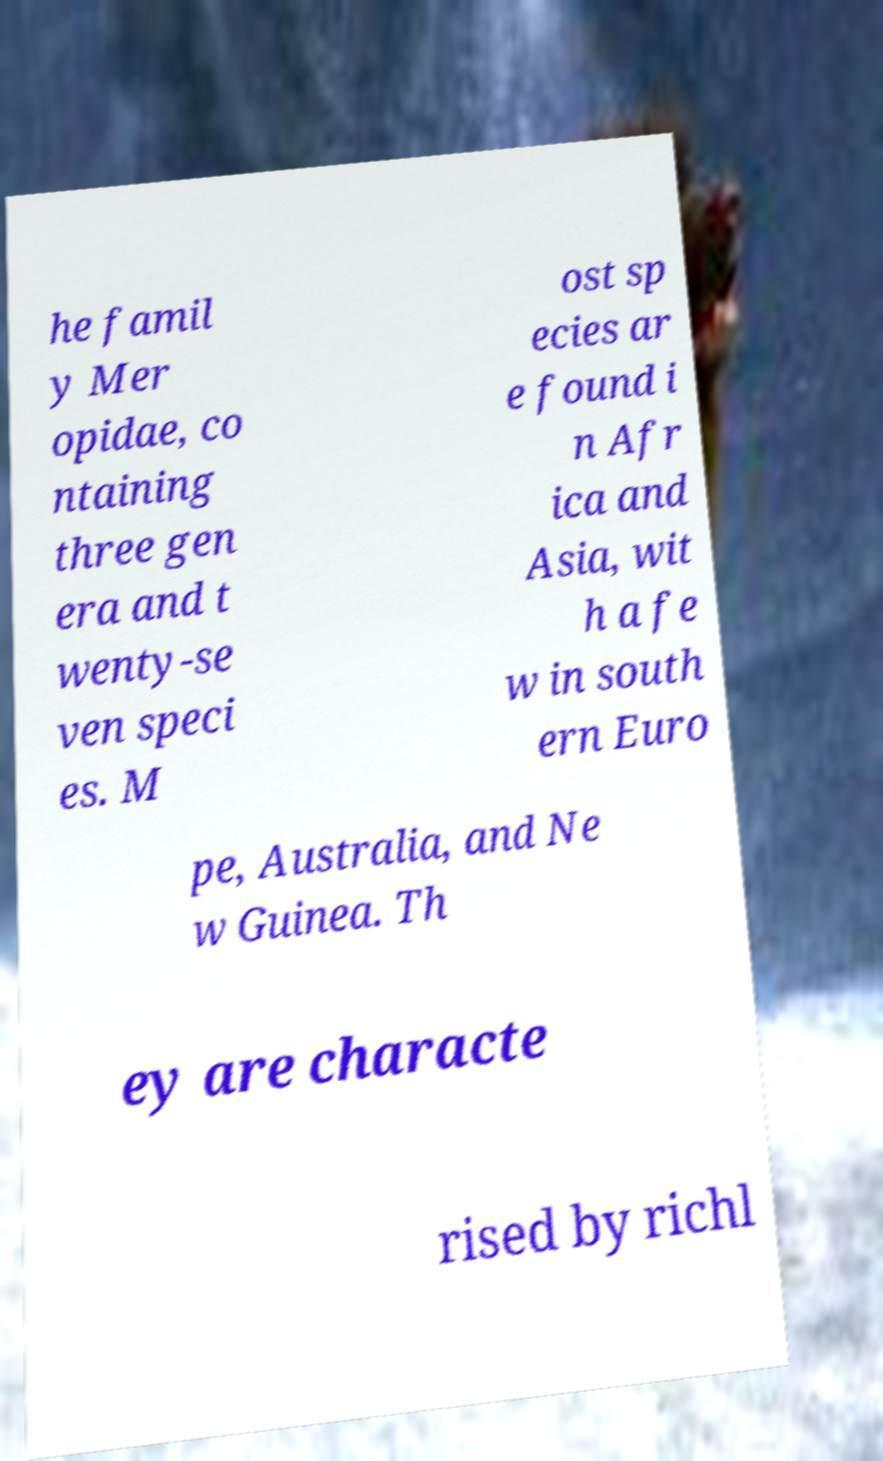Please read and relay the text visible in this image. What does it say? he famil y Mer opidae, co ntaining three gen era and t wenty-se ven speci es. M ost sp ecies ar e found i n Afr ica and Asia, wit h a fe w in south ern Euro pe, Australia, and Ne w Guinea. Th ey are characte rised by richl 